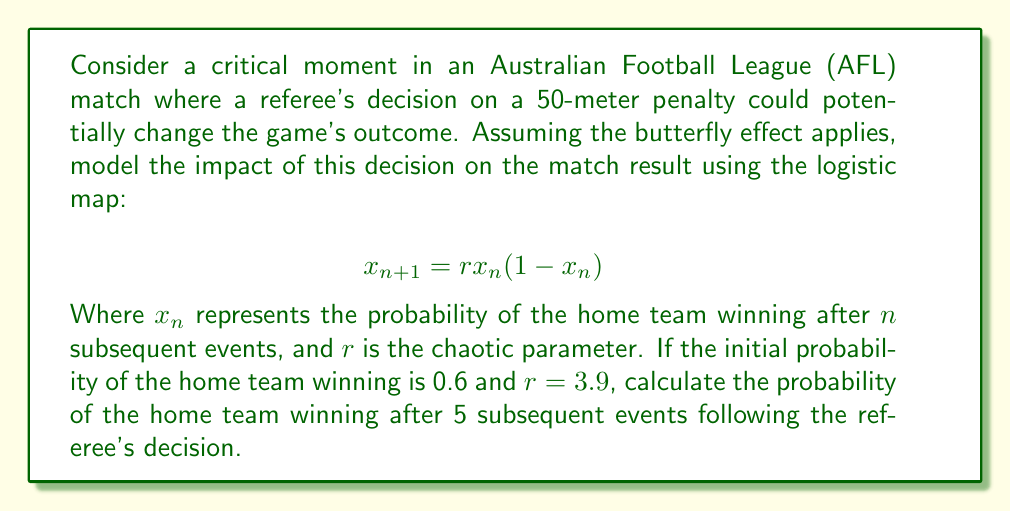Help me with this question. Let's approach this step-by-step using the logistic map equation:

1) We start with $x_0 = 0.6$ (initial probability) and $r = 3.9$

2) We need to iterate the equation 5 times:

   For $n = 0$:
   $x_1 = 3.9 * 0.6 * (1-0.6) = 0.936$

   For $n = 1$:
   $x_2 = 3.9 * 0.936 * (1-0.936) = 0.234$

   For $n = 2$:
   $x_3 = 3.9 * 0.234 * (1-0.234) = 0.700$

   For $n = 3$:
   $x_4 = 3.9 * 0.700 * (1-0.700) = 0.819$

   For $n = 4$:
   $x_5 = 3.9 * 0.819 * (1-0.819) = 0.579$

3) The final probability after 5 iterations is 0.579 or approximately 57.9%

This demonstrates how a single decision can lead to significant fluctuations in the probability of the match outcome, illustrating the butterfly effect in the context of an AFL match.
Answer: 0.579 